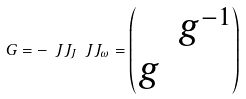Convert formula to latex. <formula><loc_0><loc_0><loc_500><loc_500>G = - \ J J _ { J } \ J J _ { \omega } = \left ( \begin{matrix} & g ^ { - 1 } \\ g & \end{matrix} \right )</formula> 